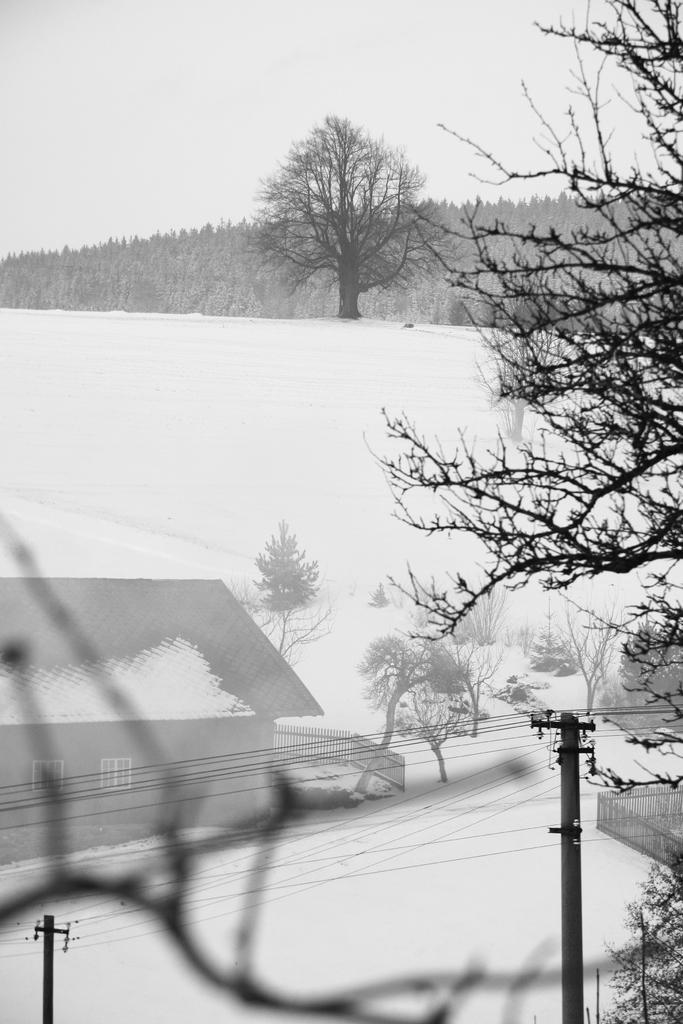Describe this image in one or two sentences. In this image we can see a house with roof covered with ice, windows and a fence on the ice. We can also see two utility poles with some wires, branches of a tree, trees and the sky. 